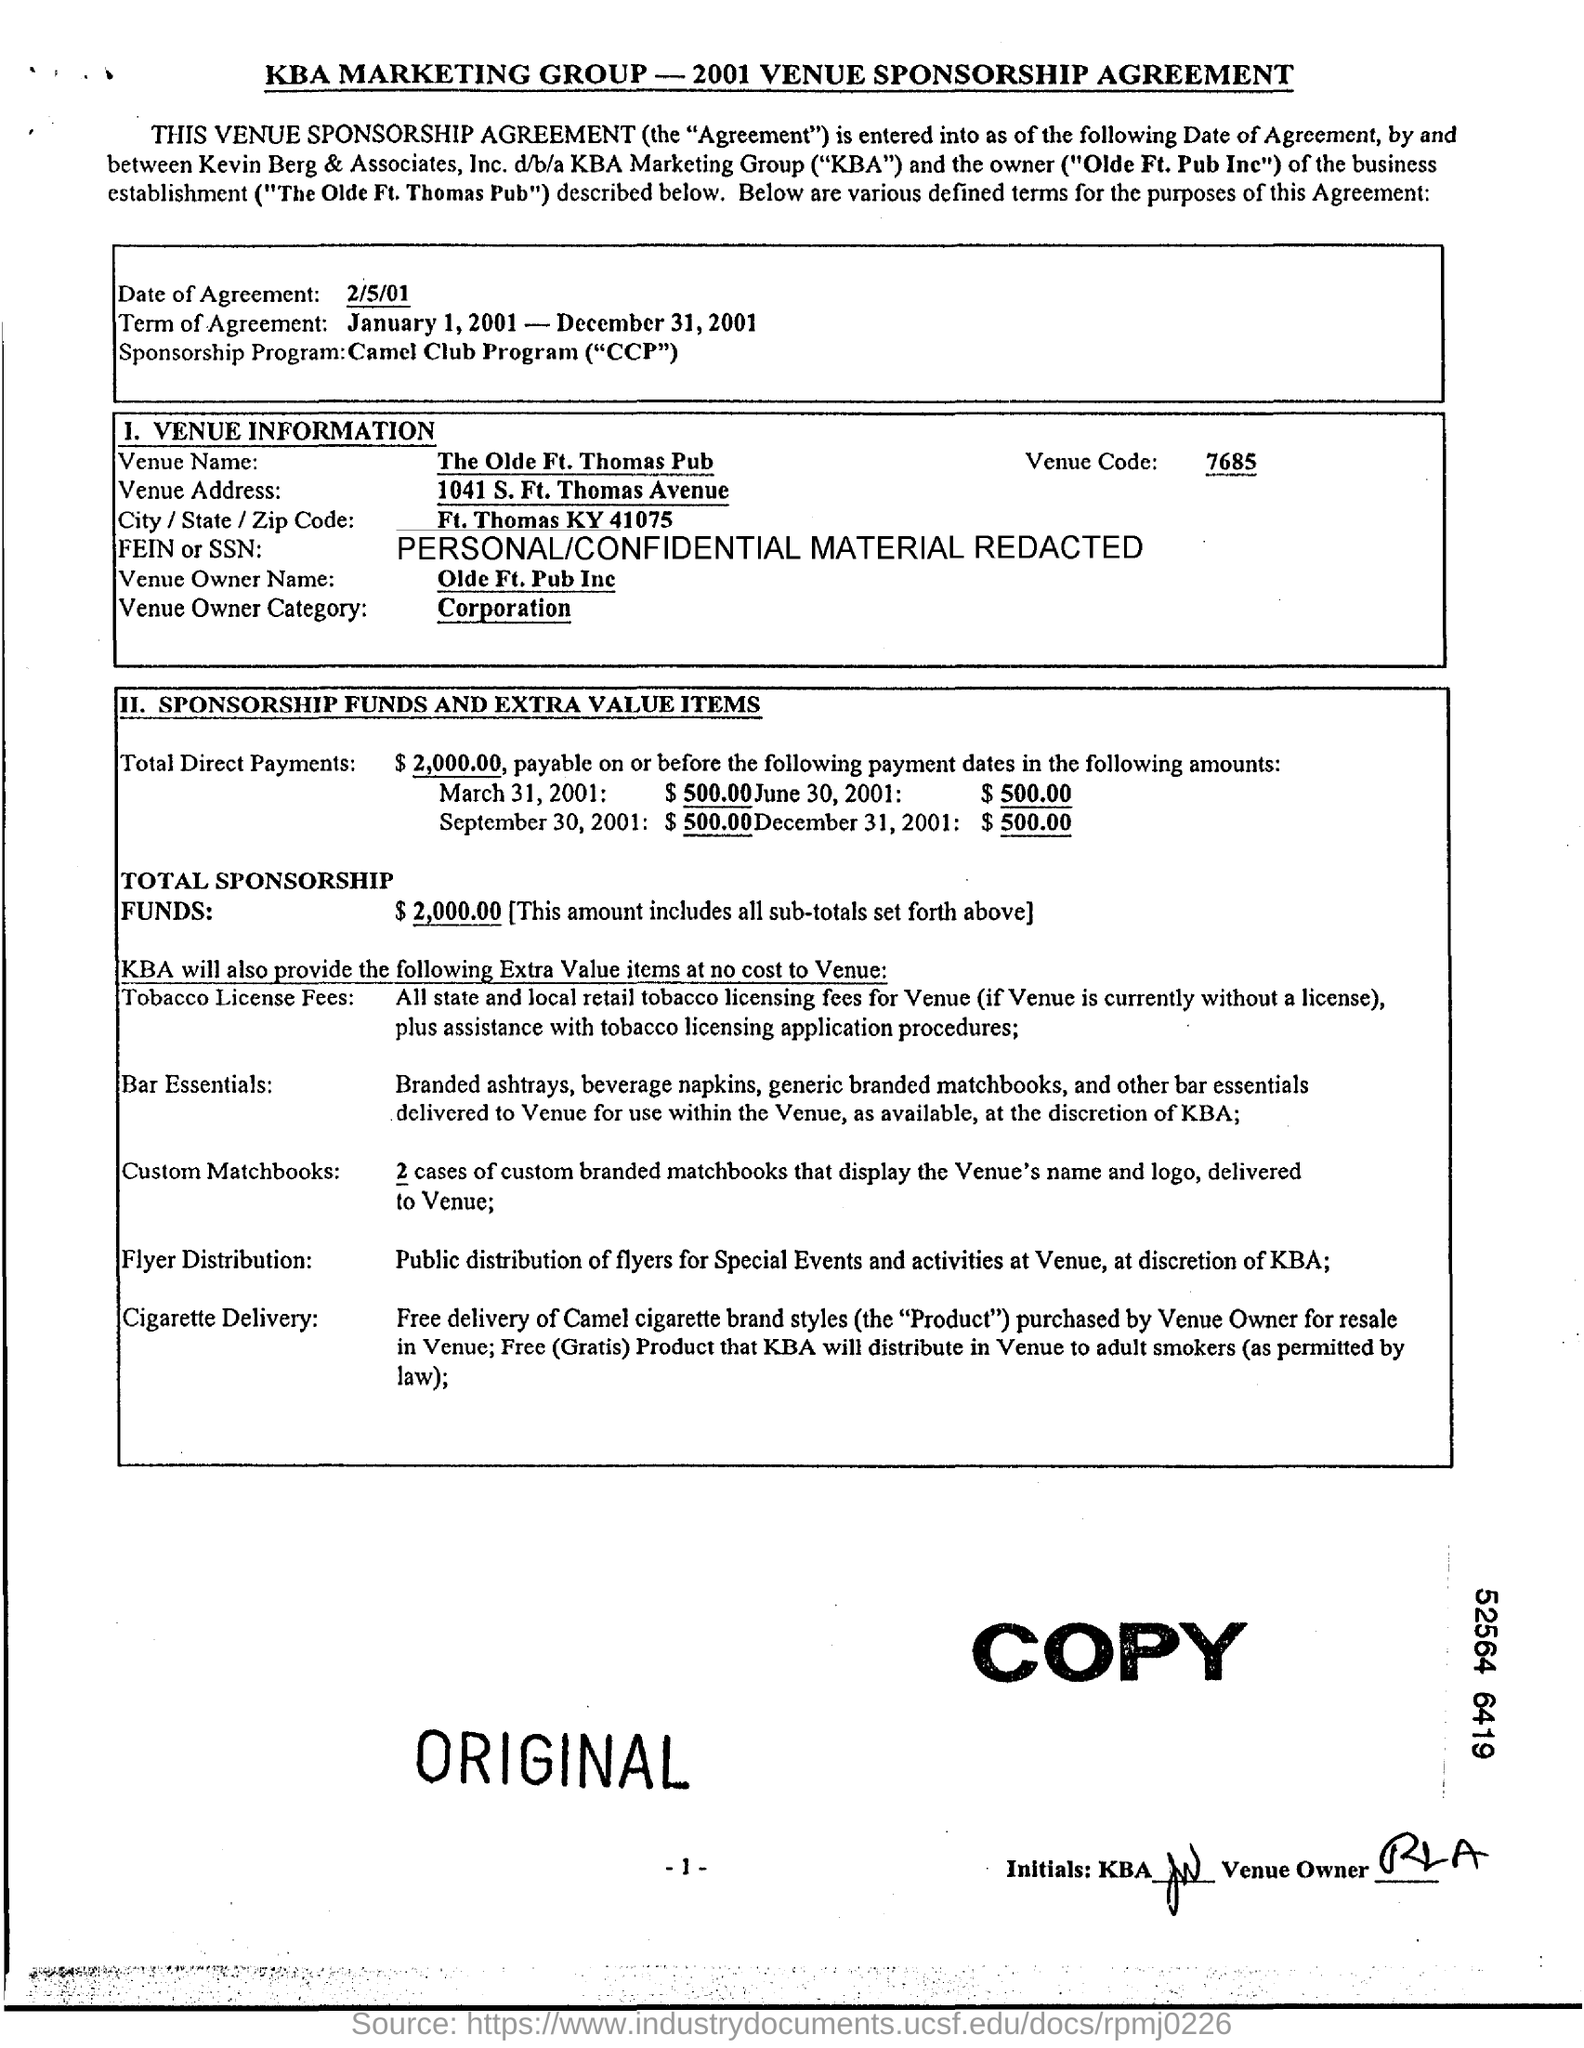Whats the venue name?
Give a very brief answer. The Olde Ft. Thomas pub. What is the Venue Owner Name?
Offer a terse response. Olde ft. pub inc. Whats the Venue Owner Category?
Offer a terse response. Corporation. 